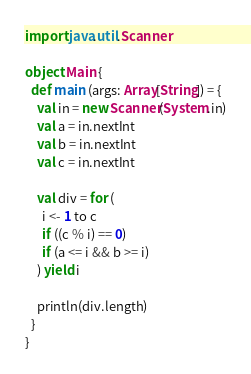Convert code to text. <code><loc_0><loc_0><loc_500><loc_500><_Scala_>import java.util.Scanner

object Main {
  def main (args: Array[String]) = {
    val in = new Scanner(System.in)
    val a = in.nextInt
    val b = in.nextInt
    val c = in.nextInt

    val div = for (
      i <- 1 to c
      if ((c % i) == 0)
      if (a <= i && b >= i)
    ) yield i

    println(div.length)
  }
}</code> 